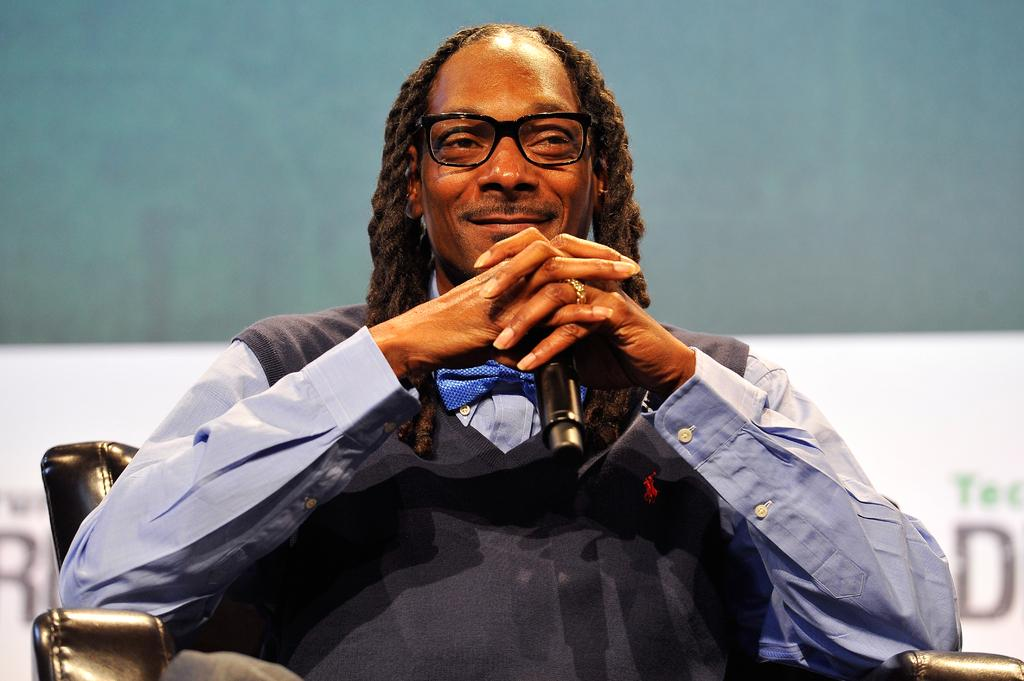What is the main subject of the image? There is a person in the image. What is the person wearing? The person is wearing a blue color shirt. Are there any accessories visible on the person? Yes, the person is wearing spectacles. What is the person's facial expression? The person is smiling. What is the person sitting on? The person is sitting on a sofa chair. What color is the background of the image? The background of the image is green. What is the price of the basket in the image? There is no basket present in the image, so it is not possible to determine its price. 